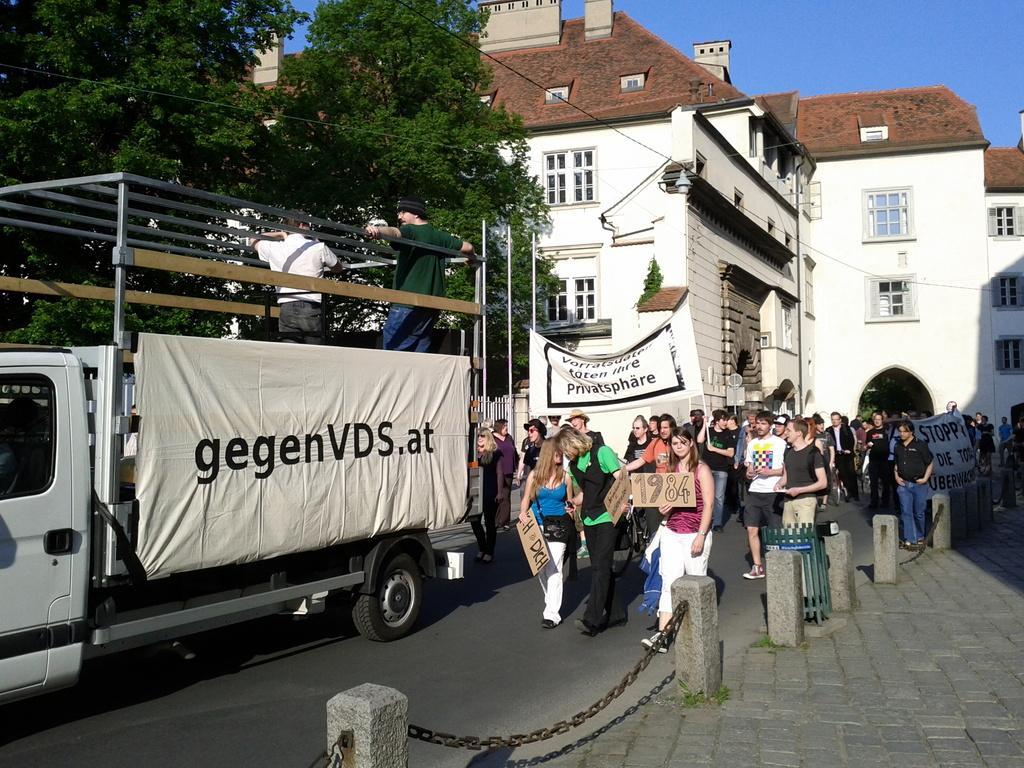Please provide a concise description of this image. In this picture I can see many people who are taking the march on the road and holding the posters and banners. On the left there is a truck. In the background I can see the buildings and trees. In the top right I can see the sky. At the bottom I can see the chains which are connected to the stones. 